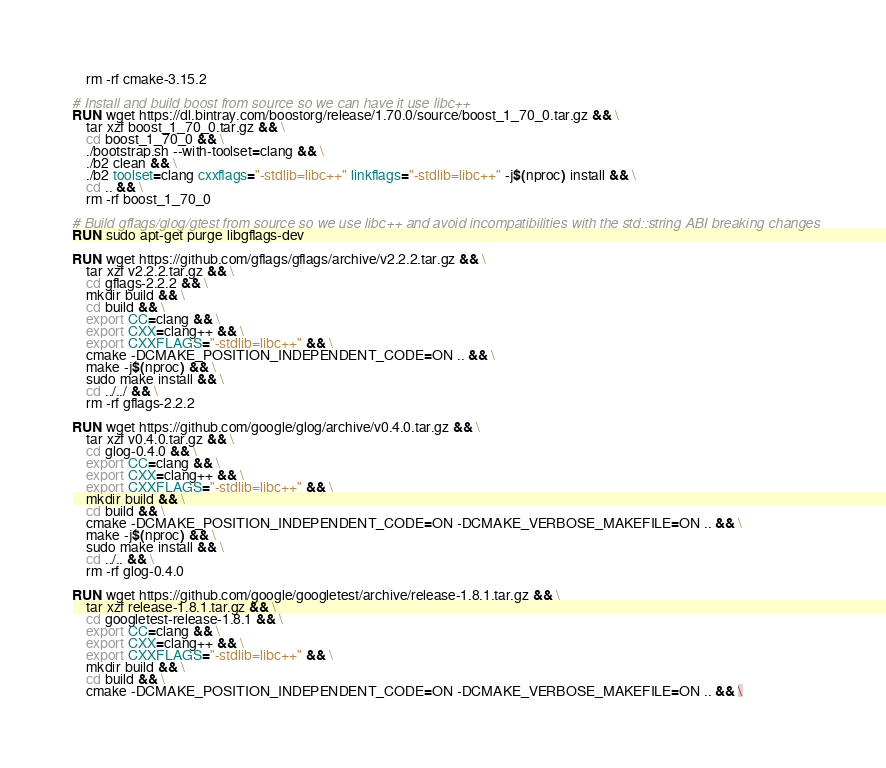Convert code to text. <code><loc_0><loc_0><loc_500><loc_500><_Dockerfile_>    rm -rf cmake-3.15.2

# Install and build boost from source so we can have it use libc++
RUN wget https://dl.bintray.com/boostorg/release/1.70.0/source/boost_1_70_0.tar.gz && \
    tar xzf boost_1_70_0.tar.gz && \
    cd boost_1_70_0 && \
    ./bootstrap.sh --with-toolset=clang && \
    ./b2 clean && \
    ./b2 toolset=clang cxxflags="-stdlib=libc++" linkflags="-stdlib=libc++" -j$(nproc) install && \
    cd .. && \
    rm -rf boost_1_70_0

# Build gflags/glog/gtest from source so we use libc++ and avoid incompatibilities with the std::string ABI breaking changes
RUN sudo apt-get purge libgflags-dev

RUN wget https://github.com/gflags/gflags/archive/v2.2.2.tar.gz && \
    tar xzf v2.2.2.tar.gz && \
    cd gflags-2.2.2 && \
    mkdir build && \
    cd build && \
    export CC=clang && \
    export CXX=clang++ && \
    export CXXFLAGS="-stdlib=libc++" && \
    cmake -DCMAKE_POSITION_INDEPENDENT_CODE=ON .. && \
    make -j$(nproc) && \
    sudo make install && \
    cd ../../ && \
    rm -rf gflags-2.2.2

RUN wget https://github.com/google/glog/archive/v0.4.0.tar.gz && \
    tar xzf v0.4.0.tar.gz && \
    cd glog-0.4.0 && \
    export CC=clang && \
    export CXX=clang++ && \
    export CXXFLAGS="-stdlib=libc++" && \
    mkdir build && \
    cd build && \
    cmake -DCMAKE_POSITION_INDEPENDENT_CODE=ON -DCMAKE_VERBOSE_MAKEFILE=ON .. && \
    make -j$(nproc) && \
    sudo make install && \
    cd ../.. && \
    rm -rf glog-0.4.0

RUN wget https://github.com/google/googletest/archive/release-1.8.1.tar.gz && \
    tar xzf release-1.8.1.tar.gz && \
    cd googletest-release-1.8.1 && \
    export CC=clang && \
    export CXX=clang++ && \
    export CXXFLAGS="-stdlib=libc++" && \
    mkdir build && \
    cd build && \
    cmake -DCMAKE_POSITION_INDEPENDENT_CODE=ON -DCMAKE_VERBOSE_MAKEFILE=ON .. && \</code> 